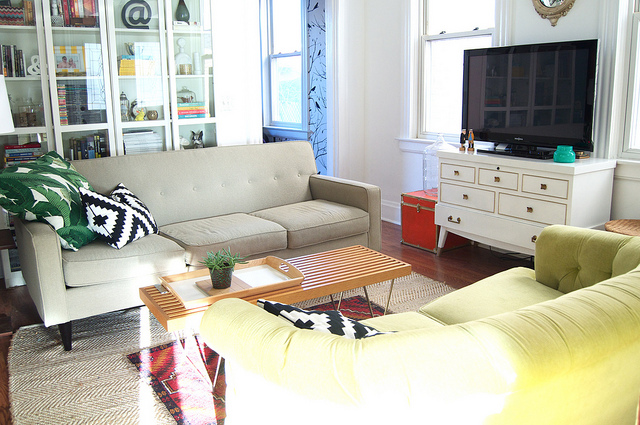Imagine you wanted to add an item to this room to enhance its functionality, what would you suggest? Considering the layout and design of the room, adding a sleek, mid-century modern-style floor lamp beside the green armchair could enhance both its functionality and aesthetic. It would provide focused light for reading or working, complementing the room's theme and increasing its practical purpose without disrupting the existing decor. 